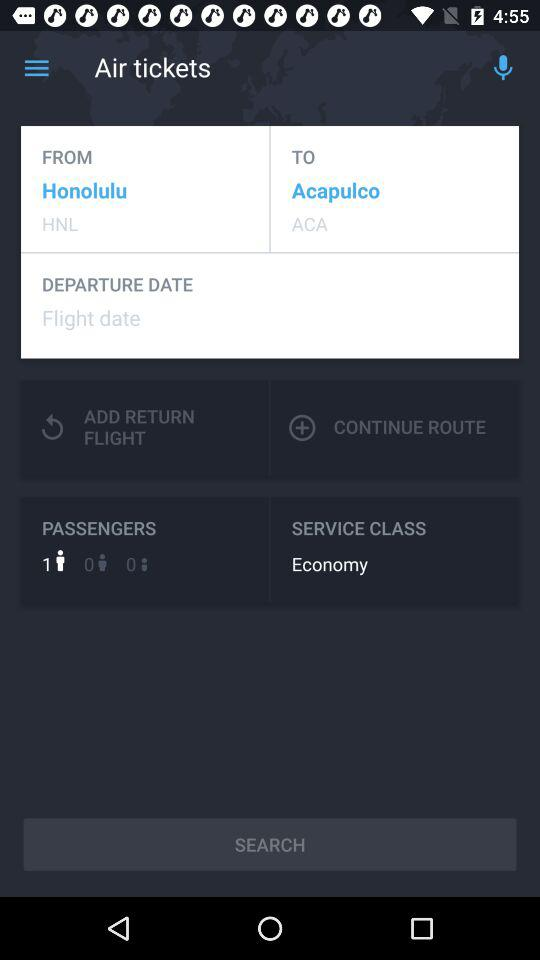What's the departure location? The departure location is Honolulu. 